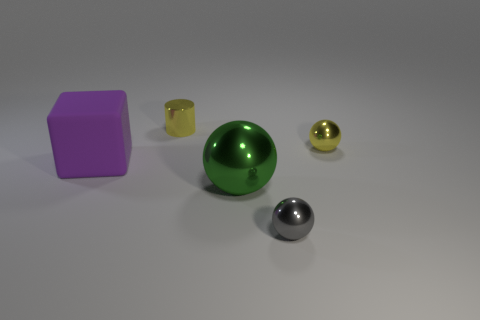There is a tiny yellow object that is on the right side of the yellow shiny cylinder; does it have the same shape as the big purple object?
Ensure brevity in your answer.  No. Is there a tiny cylinder?
Give a very brief answer. Yes. Are there any other things that have the same shape as the large green thing?
Provide a short and direct response. Yes. Are there more small metallic objects to the right of the gray object than cyan balls?
Provide a short and direct response. Yes. Are there any small yellow balls behind the cylinder?
Keep it short and to the point. No. Is the size of the gray shiny sphere the same as the purple object?
Provide a short and direct response. No. What is the size of the green shiny object that is the same shape as the small gray thing?
Offer a terse response. Large. What is the thing that is on the left side of the small metal thing that is behind the tiny yellow ball made of?
Provide a succinct answer. Rubber. Is the large green metal thing the same shape as the tiny gray metal object?
Keep it short and to the point. Yes. How many small objects are in front of the yellow metal sphere and to the left of the big green thing?
Offer a very short reply. 0. 